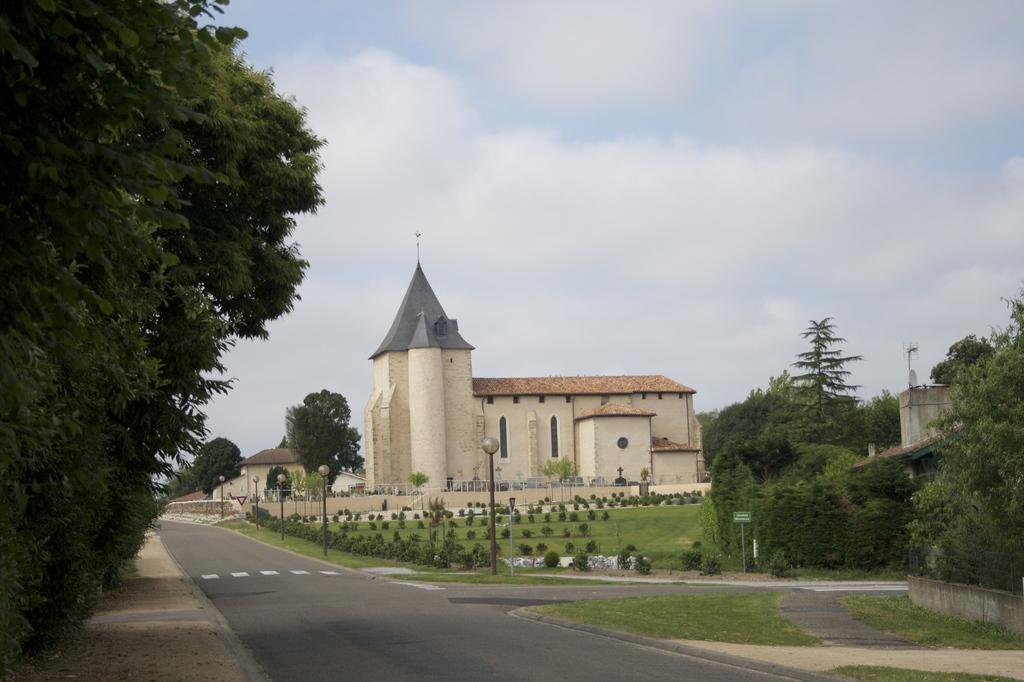What type of structures can be seen in the image? There are houses in the image. What type of natural elements are present in the image? There are plants, trees, and the sky visible in the image. What type of man-made structures are present in the image? There are light poles in the image. What type of signage is present in the image? There is a board in the image. Can you see any veins in the image? There are no veins present in the image. What type of station is visible in the image? There is no station present in the image. 